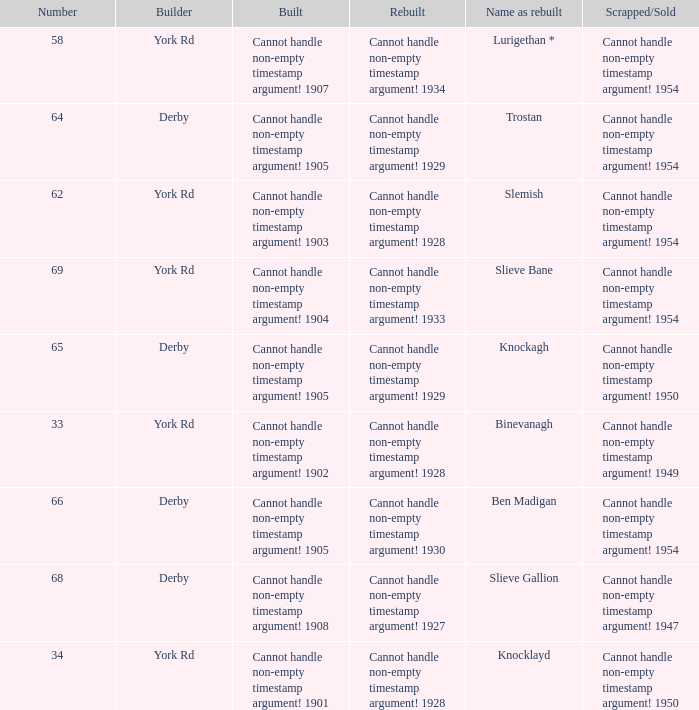Which Rebuilt has a Builder of derby, and a Name as rebuilt of ben madigan? Cannot handle non-empty timestamp argument! 1930. 